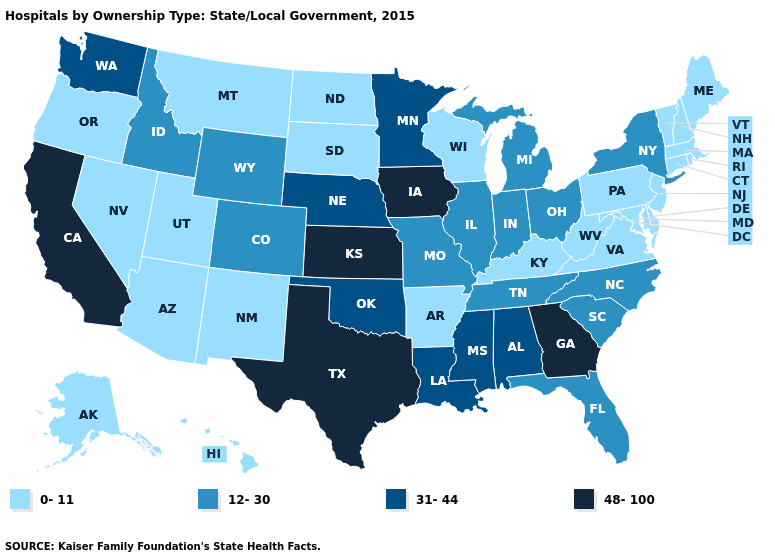Does California have the lowest value in the West?
Answer briefly. No. Among the states that border Connecticut , which have the lowest value?
Write a very short answer. Massachusetts, Rhode Island. Name the states that have a value in the range 31-44?
Write a very short answer. Alabama, Louisiana, Minnesota, Mississippi, Nebraska, Oklahoma, Washington. What is the value of Wisconsin?
Keep it brief. 0-11. What is the lowest value in the Northeast?
Keep it brief. 0-11. Which states have the highest value in the USA?
Keep it brief. California, Georgia, Iowa, Kansas, Texas. Name the states that have a value in the range 0-11?
Be succinct. Alaska, Arizona, Arkansas, Connecticut, Delaware, Hawaii, Kentucky, Maine, Maryland, Massachusetts, Montana, Nevada, New Hampshire, New Jersey, New Mexico, North Dakota, Oregon, Pennsylvania, Rhode Island, South Dakota, Utah, Vermont, Virginia, West Virginia, Wisconsin. Does Rhode Island have the lowest value in the USA?
Concise answer only. Yes. Which states have the lowest value in the West?
Write a very short answer. Alaska, Arizona, Hawaii, Montana, Nevada, New Mexico, Oregon, Utah. Name the states that have a value in the range 48-100?
Give a very brief answer. California, Georgia, Iowa, Kansas, Texas. What is the value of New Mexico?
Write a very short answer. 0-11. Name the states that have a value in the range 48-100?
Give a very brief answer. California, Georgia, Iowa, Kansas, Texas. Which states hav the highest value in the West?
Keep it brief. California. How many symbols are there in the legend?
Quick response, please. 4. Is the legend a continuous bar?
Write a very short answer. No. 